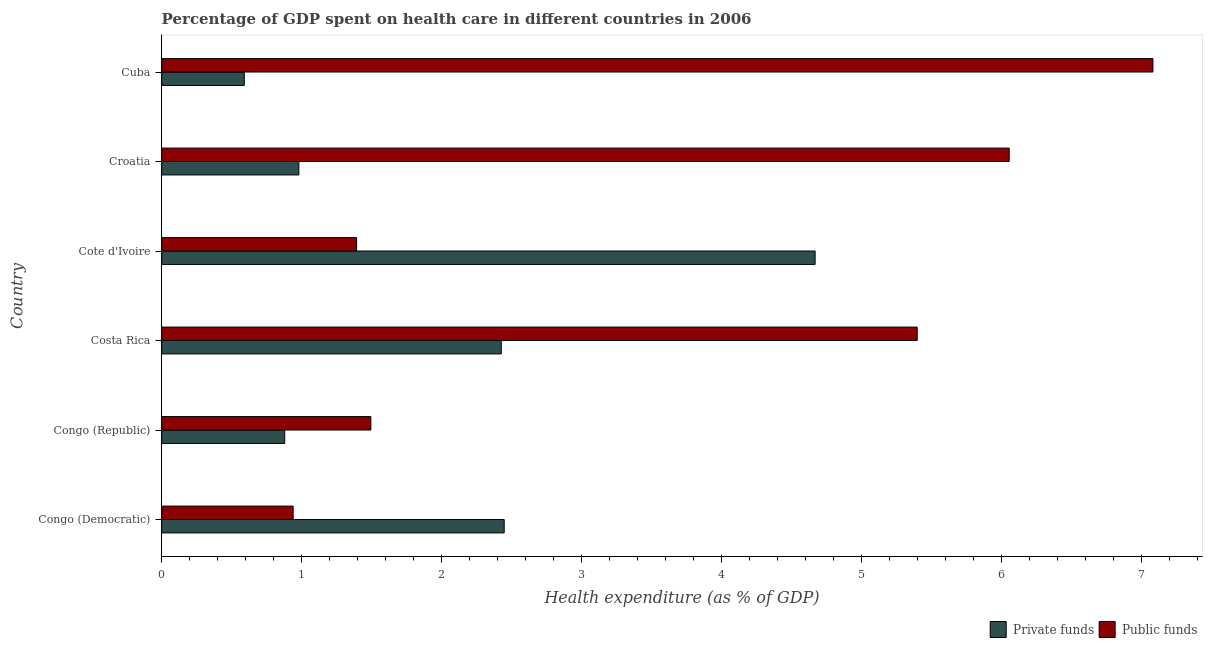How many bars are there on the 1st tick from the bottom?
Keep it short and to the point. 2. What is the label of the 3rd group of bars from the top?
Make the answer very short. Cote d'Ivoire. In how many cases, is the number of bars for a given country not equal to the number of legend labels?
Your response must be concise. 0. What is the amount of public funds spent in healthcare in Congo (Republic)?
Offer a terse response. 1.49. Across all countries, what is the maximum amount of private funds spent in healthcare?
Provide a short and direct response. 4.67. Across all countries, what is the minimum amount of public funds spent in healthcare?
Your answer should be compact. 0.94. In which country was the amount of private funds spent in healthcare maximum?
Your answer should be very brief. Cote d'Ivoire. In which country was the amount of private funds spent in healthcare minimum?
Your answer should be compact. Cuba. What is the total amount of public funds spent in healthcare in the graph?
Offer a very short reply. 22.36. What is the difference between the amount of public funds spent in healthcare in Congo (Democratic) and that in Congo (Republic)?
Give a very brief answer. -0.56. What is the difference between the amount of private funds spent in healthcare in Croatia and the amount of public funds spent in healthcare in Cote d'Ivoire?
Give a very brief answer. -0.41. What is the average amount of public funds spent in healthcare per country?
Your answer should be compact. 3.73. What is the difference between the amount of public funds spent in healthcare and amount of private funds spent in healthcare in Congo (Republic)?
Offer a very short reply. 0.61. What is the ratio of the amount of private funds spent in healthcare in Congo (Democratic) to that in Croatia?
Give a very brief answer. 2.5. What is the difference between the highest and the second highest amount of public funds spent in healthcare?
Make the answer very short. 1.03. What is the difference between the highest and the lowest amount of private funds spent in healthcare?
Your answer should be compact. 4.08. What does the 2nd bar from the top in Congo (Democratic) represents?
Offer a terse response. Private funds. What does the 1st bar from the bottom in Cuba represents?
Provide a short and direct response. Private funds. Are all the bars in the graph horizontal?
Give a very brief answer. Yes. How many countries are there in the graph?
Give a very brief answer. 6. Are the values on the major ticks of X-axis written in scientific E-notation?
Your answer should be very brief. No. Where does the legend appear in the graph?
Provide a short and direct response. Bottom right. How are the legend labels stacked?
Make the answer very short. Horizontal. What is the title of the graph?
Your response must be concise. Percentage of GDP spent on health care in different countries in 2006. What is the label or title of the X-axis?
Keep it short and to the point. Health expenditure (as % of GDP). What is the Health expenditure (as % of GDP) of Private funds in Congo (Democratic)?
Offer a terse response. 2.45. What is the Health expenditure (as % of GDP) of Public funds in Congo (Democratic)?
Offer a terse response. 0.94. What is the Health expenditure (as % of GDP) in Private funds in Congo (Republic)?
Make the answer very short. 0.88. What is the Health expenditure (as % of GDP) of Public funds in Congo (Republic)?
Offer a terse response. 1.49. What is the Health expenditure (as % of GDP) in Private funds in Costa Rica?
Your answer should be compact. 2.43. What is the Health expenditure (as % of GDP) of Public funds in Costa Rica?
Give a very brief answer. 5.4. What is the Health expenditure (as % of GDP) in Private funds in Cote d'Ivoire?
Offer a terse response. 4.67. What is the Health expenditure (as % of GDP) of Public funds in Cote d'Ivoire?
Your answer should be very brief. 1.39. What is the Health expenditure (as % of GDP) of Private funds in Croatia?
Keep it short and to the point. 0.98. What is the Health expenditure (as % of GDP) in Public funds in Croatia?
Offer a very short reply. 6.05. What is the Health expenditure (as % of GDP) of Private funds in Cuba?
Your answer should be very brief. 0.59. What is the Health expenditure (as % of GDP) in Public funds in Cuba?
Offer a terse response. 7.08. Across all countries, what is the maximum Health expenditure (as % of GDP) of Private funds?
Your answer should be compact. 4.67. Across all countries, what is the maximum Health expenditure (as % of GDP) in Public funds?
Make the answer very short. 7.08. Across all countries, what is the minimum Health expenditure (as % of GDP) of Private funds?
Offer a terse response. 0.59. Across all countries, what is the minimum Health expenditure (as % of GDP) in Public funds?
Provide a short and direct response. 0.94. What is the total Health expenditure (as % of GDP) in Private funds in the graph?
Keep it short and to the point. 11.99. What is the total Health expenditure (as % of GDP) in Public funds in the graph?
Ensure brevity in your answer.  22.36. What is the difference between the Health expenditure (as % of GDP) in Private funds in Congo (Democratic) and that in Congo (Republic)?
Offer a terse response. 1.57. What is the difference between the Health expenditure (as % of GDP) in Public funds in Congo (Democratic) and that in Congo (Republic)?
Provide a succinct answer. -0.56. What is the difference between the Health expenditure (as % of GDP) in Private funds in Congo (Democratic) and that in Costa Rica?
Give a very brief answer. 0.02. What is the difference between the Health expenditure (as % of GDP) of Public funds in Congo (Democratic) and that in Costa Rica?
Your response must be concise. -4.46. What is the difference between the Health expenditure (as % of GDP) in Private funds in Congo (Democratic) and that in Cote d'Ivoire?
Ensure brevity in your answer.  -2.22. What is the difference between the Health expenditure (as % of GDP) of Public funds in Congo (Democratic) and that in Cote d'Ivoire?
Make the answer very short. -0.45. What is the difference between the Health expenditure (as % of GDP) in Private funds in Congo (Democratic) and that in Croatia?
Offer a very short reply. 1.47. What is the difference between the Health expenditure (as % of GDP) in Public funds in Congo (Democratic) and that in Croatia?
Your answer should be compact. -5.12. What is the difference between the Health expenditure (as % of GDP) in Private funds in Congo (Democratic) and that in Cuba?
Your response must be concise. 1.86. What is the difference between the Health expenditure (as % of GDP) of Public funds in Congo (Democratic) and that in Cuba?
Provide a short and direct response. -6.14. What is the difference between the Health expenditure (as % of GDP) in Private funds in Congo (Republic) and that in Costa Rica?
Give a very brief answer. -1.55. What is the difference between the Health expenditure (as % of GDP) in Public funds in Congo (Republic) and that in Costa Rica?
Offer a very short reply. -3.9. What is the difference between the Health expenditure (as % of GDP) in Private funds in Congo (Republic) and that in Cote d'Ivoire?
Your answer should be compact. -3.79. What is the difference between the Health expenditure (as % of GDP) of Public funds in Congo (Republic) and that in Cote d'Ivoire?
Offer a terse response. 0.1. What is the difference between the Health expenditure (as % of GDP) of Private funds in Congo (Republic) and that in Croatia?
Keep it short and to the point. -0.1. What is the difference between the Health expenditure (as % of GDP) in Public funds in Congo (Republic) and that in Croatia?
Your response must be concise. -4.56. What is the difference between the Health expenditure (as % of GDP) of Private funds in Congo (Republic) and that in Cuba?
Keep it short and to the point. 0.29. What is the difference between the Health expenditure (as % of GDP) in Public funds in Congo (Republic) and that in Cuba?
Your answer should be very brief. -5.59. What is the difference between the Health expenditure (as % of GDP) of Private funds in Costa Rica and that in Cote d'Ivoire?
Provide a succinct answer. -2.24. What is the difference between the Health expenditure (as % of GDP) in Public funds in Costa Rica and that in Cote d'Ivoire?
Your response must be concise. 4. What is the difference between the Health expenditure (as % of GDP) of Private funds in Costa Rica and that in Croatia?
Keep it short and to the point. 1.45. What is the difference between the Health expenditure (as % of GDP) in Public funds in Costa Rica and that in Croatia?
Your answer should be compact. -0.66. What is the difference between the Health expenditure (as % of GDP) of Private funds in Costa Rica and that in Cuba?
Offer a very short reply. 1.84. What is the difference between the Health expenditure (as % of GDP) of Public funds in Costa Rica and that in Cuba?
Provide a succinct answer. -1.68. What is the difference between the Health expenditure (as % of GDP) of Private funds in Cote d'Ivoire and that in Croatia?
Your answer should be compact. 3.69. What is the difference between the Health expenditure (as % of GDP) in Public funds in Cote d'Ivoire and that in Croatia?
Make the answer very short. -4.66. What is the difference between the Health expenditure (as % of GDP) of Private funds in Cote d'Ivoire and that in Cuba?
Your response must be concise. 4.08. What is the difference between the Health expenditure (as % of GDP) of Public funds in Cote d'Ivoire and that in Cuba?
Your response must be concise. -5.69. What is the difference between the Health expenditure (as % of GDP) of Private funds in Croatia and that in Cuba?
Ensure brevity in your answer.  0.39. What is the difference between the Health expenditure (as % of GDP) of Public funds in Croatia and that in Cuba?
Provide a succinct answer. -1.03. What is the difference between the Health expenditure (as % of GDP) in Private funds in Congo (Democratic) and the Health expenditure (as % of GDP) in Public funds in Congo (Republic)?
Keep it short and to the point. 0.95. What is the difference between the Health expenditure (as % of GDP) in Private funds in Congo (Democratic) and the Health expenditure (as % of GDP) in Public funds in Costa Rica?
Provide a short and direct response. -2.95. What is the difference between the Health expenditure (as % of GDP) of Private funds in Congo (Democratic) and the Health expenditure (as % of GDP) of Public funds in Cote d'Ivoire?
Keep it short and to the point. 1.05. What is the difference between the Health expenditure (as % of GDP) in Private funds in Congo (Democratic) and the Health expenditure (as % of GDP) in Public funds in Croatia?
Provide a succinct answer. -3.61. What is the difference between the Health expenditure (as % of GDP) in Private funds in Congo (Democratic) and the Health expenditure (as % of GDP) in Public funds in Cuba?
Your answer should be compact. -4.63. What is the difference between the Health expenditure (as % of GDP) of Private funds in Congo (Republic) and the Health expenditure (as % of GDP) of Public funds in Costa Rica?
Provide a short and direct response. -4.52. What is the difference between the Health expenditure (as % of GDP) in Private funds in Congo (Republic) and the Health expenditure (as % of GDP) in Public funds in Cote d'Ivoire?
Keep it short and to the point. -0.51. What is the difference between the Health expenditure (as % of GDP) of Private funds in Congo (Republic) and the Health expenditure (as % of GDP) of Public funds in Croatia?
Your answer should be compact. -5.18. What is the difference between the Health expenditure (as % of GDP) in Private funds in Congo (Republic) and the Health expenditure (as % of GDP) in Public funds in Cuba?
Your response must be concise. -6.2. What is the difference between the Health expenditure (as % of GDP) of Private funds in Costa Rica and the Health expenditure (as % of GDP) of Public funds in Cote d'Ivoire?
Offer a very short reply. 1.03. What is the difference between the Health expenditure (as % of GDP) of Private funds in Costa Rica and the Health expenditure (as % of GDP) of Public funds in Croatia?
Provide a succinct answer. -3.63. What is the difference between the Health expenditure (as % of GDP) in Private funds in Costa Rica and the Health expenditure (as % of GDP) in Public funds in Cuba?
Provide a succinct answer. -4.66. What is the difference between the Health expenditure (as % of GDP) of Private funds in Cote d'Ivoire and the Health expenditure (as % of GDP) of Public funds in Croatia?
Make the answer very short. -1.39. What is the difference between the Health expenditure (as % of GDP) in Private funds in Cote d'Ivoire and the Health expenditure (as % of GDP) in Public funds in Cuba?
Offer a very short reply. -2.41. What is the difference between the Health expenditure (as % of GDP) of Private funds in Croatia and the Health expenditure (as % of GDP) of Public funds in Cuba?
Keep it short and to the point. -6.1. What is the average Health expenditure (as % of GDP) in Private funds per country?
Keep it short and to the point. 2. What is the average Health expenditure (as % of GDP) in Public funds per country?
Offer a very short reply. 3.73. What is the difference between the Health expenditure (as % of GDP) of Private funds and Health expenditure (as % of GDP) of Public funds in Congo (Democratic)?
Provide a short and direct response. 1.51. What is the difference between the Health expenditure (as % of GDP) of Private funds and Health expenditure (as % of GDP) of Public funds in Congo (Republic)?
Provide a short and direct response. -0.62. What is the difference between the Health expenditure (as % of GDP) of Private funds and Health expenditure (as % of GDP) of Public funds in Costa Rica?
Keep it short and to the point. -2.97. What is the difference between the Health expenditure (as % of GDP) in Private funds and Health expenditure (as % of GDP) in Public funds in Cote d'Ivoire?
Keep it short and to the point. 3.28. What is the difference between the Health expenditure (as % of GDP) in Private funds and Health expenditure (as % of GDP) in Public funds in Croatia?
Provide a succinct answer. -5.07. What is the difference between the Health expenditure (as % of GDP) in Private funds and Health expenditure (as % of GDP) in Public funds in Cuba?
Your answer should be very brief. -6.49. What is the ratio of the Health expenditure (as % of GDP) in Private funds in Congo (Democratic) to that in Congo (Republic)?
Offer a very short reply. 2.78. What is the ratio of the Health expenditure (as % of GDP) in Public funds in Congo (Democratic) to that in Congo (Republic)?
Ensure brevity in your answer.  0.63. What is the ratio of the Health expenditure (as % of GDP) of Private funds in Congo (Democratic) to that in Costa Rica?
Ensure brevity in your answer.  1.01. What is the ratio of the Health expenditure (as % of GDP) of Public funds in Congo (Democratic) to that in Costa Rica?
Your answer should be compact. 0.17. What is the ratio of the Health expenditure (as % of GDP) of Private funds in Congo (Democratic) to that in Cote d'Ivoire?
Make the answer very short. 0.52. What is the ratio of the Health expenditure (as % of GDP) in Public funds in Congo (Democratic) to that in Cote d'Ivoire?
Your answer should be compact. 0.67. What is the ratio of the Health expenditure (as % of GDP) in Private funds in Congo (Democratic) to that in Croatia?
Your response must be concise. 2.5. What is the ratio of the Health expenditure (as % of GDP) of Public funds in Congo (Democratic) to that in Croatia?
Your answer should be compact. 0.16. What is the ratio of the Health expenditure (as % of GDP) of Private funds in Congo (Democratic) to that in Cuba?
Your answer should be compact. 4.15. What is the ratio of the Health expenditure (as % of GDP) of Public funds in Congo (Democratic) to that in Cuba?
Your answer should be very brief. 0.13. What is the ratio of the Health expenditure (as % of GDP) of Private funds in Congo (Republic) to that in Costa Rica?
Provide a succinct answer. 0.36. What is the ratio of the Health expenditure (as % of GDP) of Public funds in Congo (Republic) to that in Costa Rica?
Offer a very short reply. 0.28. What is the ratio of the Health expenditure (as % of GDP) in Private funds in Congo (Republic) to that in Cote d'Ivoire?
Give a very brief answer. 0.19. What is the ratio of the Health expenditure (as % of GDP) in Public funds in Congo (Republic) to that in Cote d'Ivoire?
Provide a short and direct response. 1.07. What is the ratio of the Health expenditure (as % of GDP) in Private funds in Congo (Republic) to that in Croatia?
Offer a terse response. 0.9. What is the ratio of the Health expenditure (as % of GDP) of Public funds in Congo (Republic) to that in Croatia?
Your answer should be compact. 0.25. What is the ratio of the Health expenditure (as % of GDP) of Private funds in Congo (Republic) to that in Cuba?
Offer a very short reply. 1.49. What is the ratio of the Health expenditure (as % of GDP) of Public funds in Congo (Republic) to that in Cuba?
Give a very brief answer. 0.21. What is the ratio of the Health expenditure (as % of GDP) of Private funds in Costa Rica to that in Cote d'Ivoire?
Provide a short and direct response. 0.52. What is the ratio of the Health expenditure (as % of GDP) in Public funds in Costa Rica to that in Cote d'Ivoire?
Your answer should be compact. 3.88. What is the ratio of the Health expenditure (as % of GDP) of Private funds in Costa Rica to that in Croatia?
Your answer should be very brief. 2.48. What is the ratio of the Health expenditure (as % of GDP) of Public funds in Costa Rica to that in Croatia?
Make the answer very short. 0.89. What is the ratio of the Health expenditure (as % of GDP) of Private funds in Costa Rica to that in Cuba?
Keep it short and to the point. 4.11. What is the ratio of the Health expenditure (as % of GDP) of Public funds in Costa Rica to that in Cuba?
Provide a short and direct response. 0.76. What is the ratio of the Health expenditure (as % of GDP) of Private funds in Cote d'Ivoire to that in Croatia?
Your answer should be very brief. 4.76. What is the ratio of the Health expenditure (as % of GDP) of Public funds in Cote d'Ivoire to that in Croatia?
Your response must be concise. 0.23. What is the ratio of the Health expenditure (as % of GDP) in Private funds in Cote d'Ivoire to that in Cuba?
Provide a succinct answer. 7.91. What is the ratio of the Health expenditure (as % of GDP) in Public funds in Cote d'Ivoire to that in Cuba?
Make the answer very short. 0.2. What is the ratio of the Health expenditure (as % of GDP) of Private funds in Croatia to that in Cuba?
Your answer should be very brief. 1.66. What is the ratio of the Health expenditure (as % of GDP) of Public funds in Croatia to that in Cuba?
Ensure brevity in your answer.  0.85. What is the difference between the highest and the second highest Health expenditure (as % of GDP) in Private funds?
Offer a terse response. 2.22. What is the difference between the highest and the second highest Health expenditure (as % of GDP) of Public funds?
Make the answer very short. 1.03. What is the difference between the highest and the lowest Health expenditure (as % of GDP) in Private funds?
Your answer should be very brief. 4.08. What is the difference between the highest and the lowest Health expenditure (as % of GDP) of Public funds?
Your answer should be very brief. 6.14. 